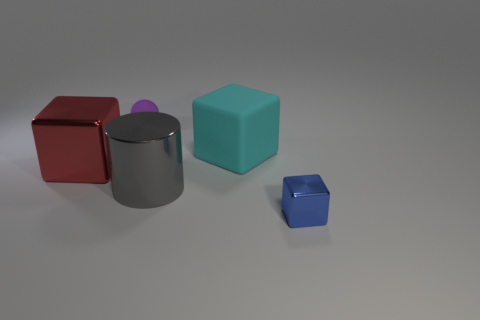Subtract all gray cubes. Subtract all red balls. How many cubes are left? 3 Add 5 cyan spheres. How many objects exist? 10 Subtract all cylinders. How many objects are left? 4 Add 5 tiny spheres. How many tiny spheres are left? 6 Add 4 gray shiny things. How many gray shiny things exist? 5 Subtract 0 red cylinders. How many objects are left? 5 Subtract all large cyan rubber things. Subtract all large metal cylinders. How many objects are left? 3 